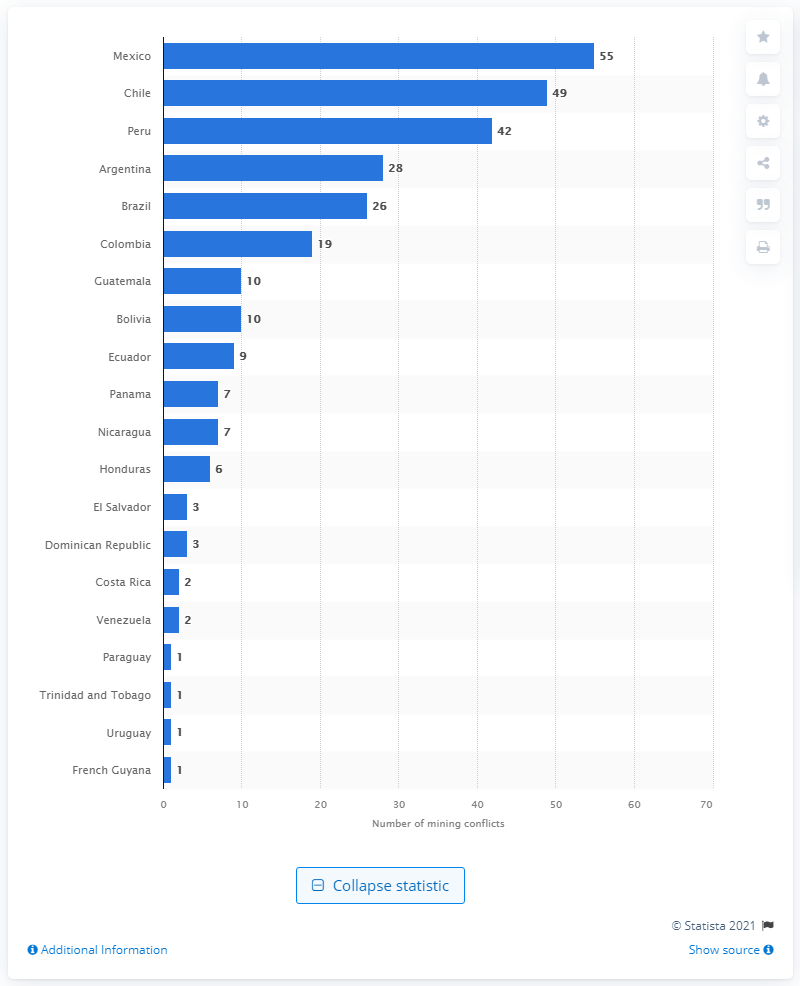List a handful of essential elements in this visual. As of June 2020, there were 55 reported mining conflicts in Mexico. As of June 2020, there were 42 mining conflicts registered in Peru. 